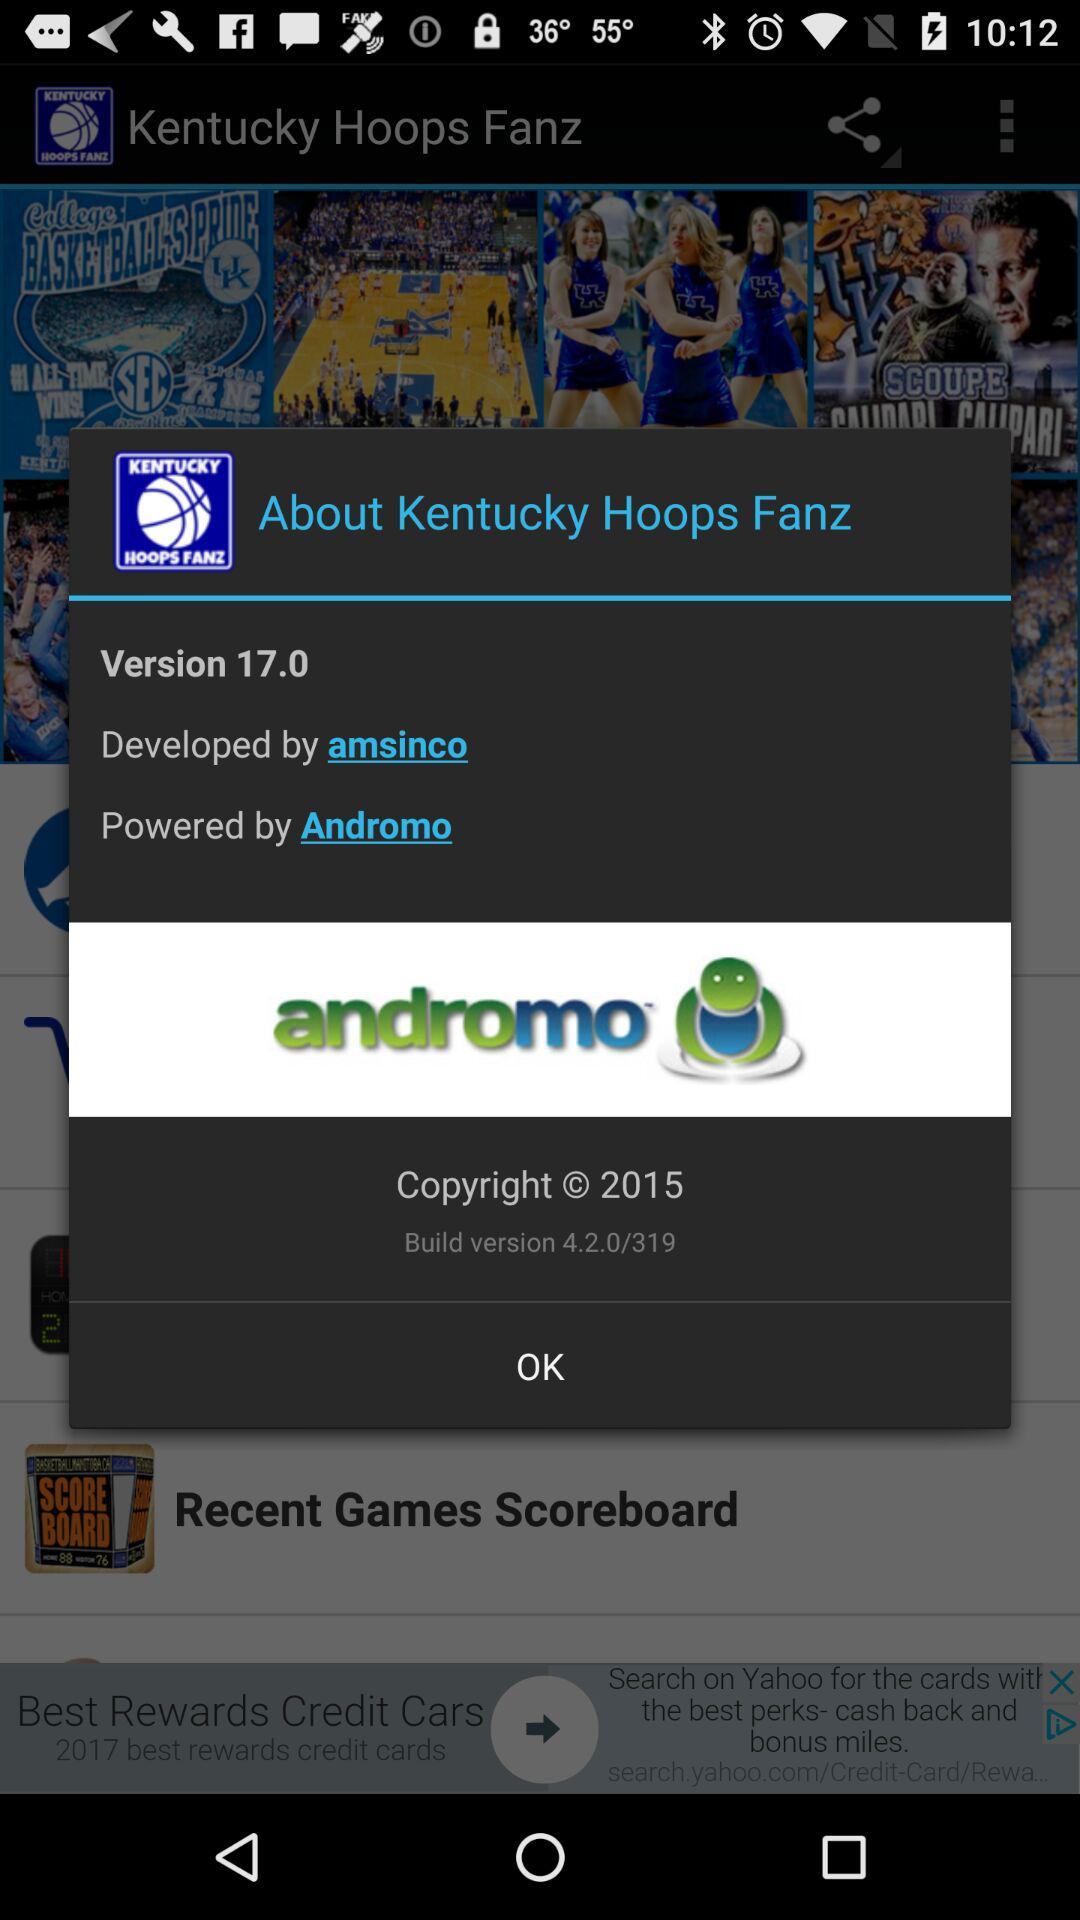Which company has powered "Kentucky Hoops Fanz"? "Kentucky Hoops Fanz" is powered by "Andromo". 